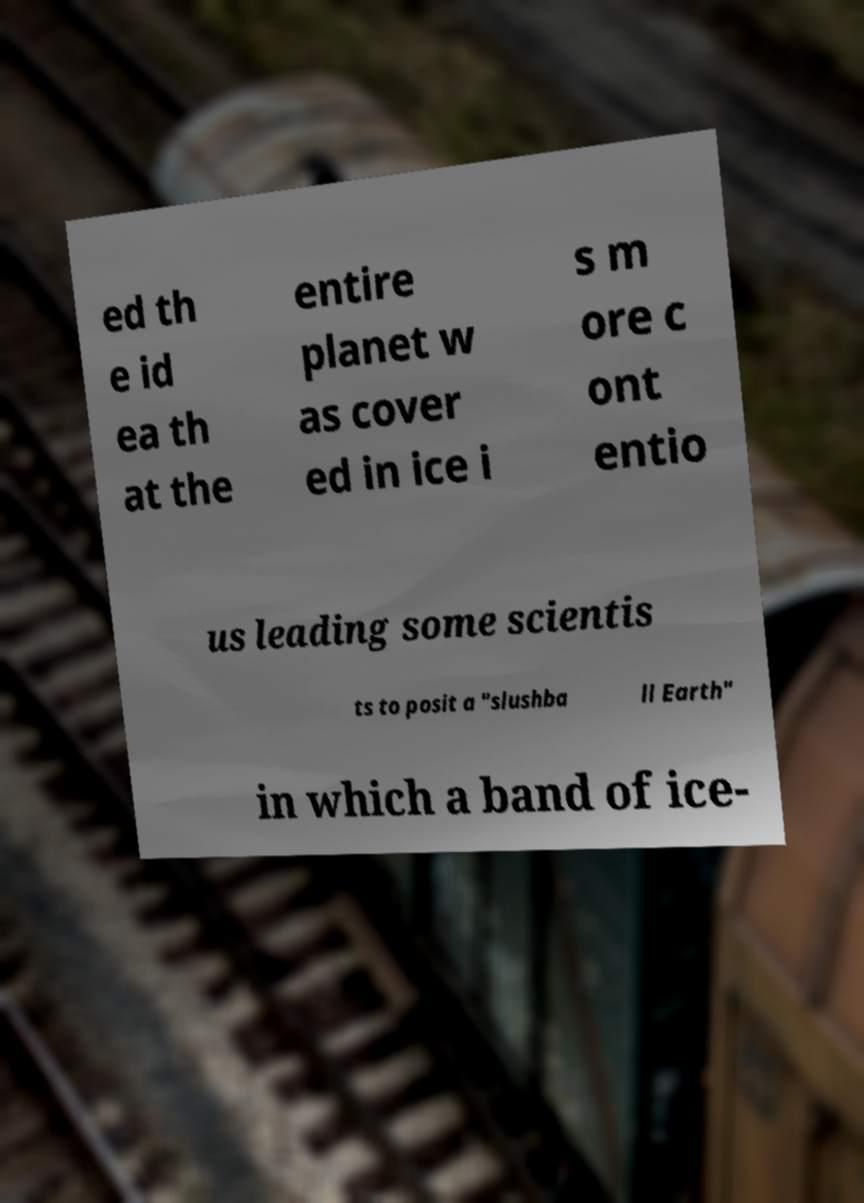Could you assist in decoding the text presented in this image and type it out clearly? ed th e id ea th at the entire planet w as cover ed in ice i s m ore c ont entio us leading some scientis ts to posit a "slushba ll Earth" in which a band of ice- 